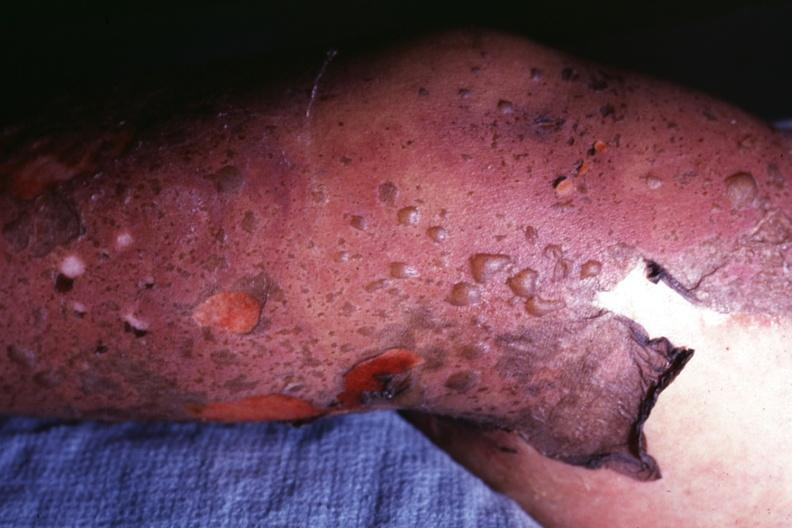s this sure what it looks like?
Answer the question using a single word or phrase. Yes 